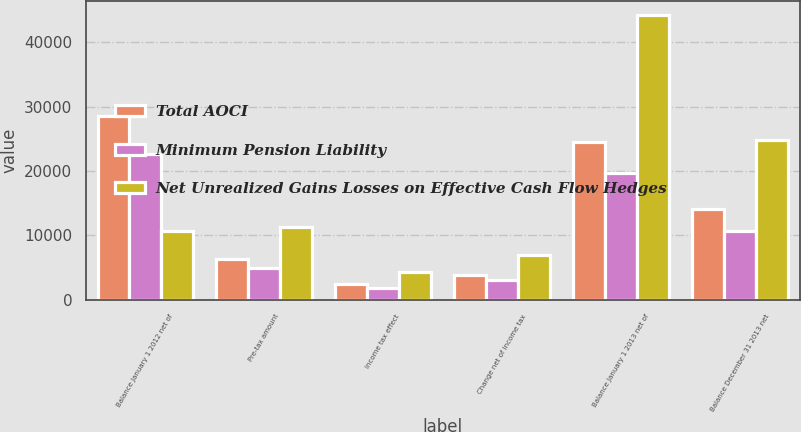<chart> <loc_0><loc_0><loc_500><loc_500><stacked_bar_chart><ecel><fcel>Balance January 1 2012 net of<fcel>Pre-tax amount<fcel>Income tax effect<fcel>Change net of income tax<fcel>Balance January 1 2013 net of<fcel>Balance December 31 2013 net<nl><fcel>Total AOCI<fcel>28460<fcel>6341<fcel>2408<fcel>3933<fcel>24527<fcel>14170<nl><fcel>Minimum Pension Liability<fcel>22715<fcel>4986<fcel>1898<fcel>3088<fcel>19627<fcel>10640<nl><fcel>Net Unrealized Gains Losses on Effective Cash Flow Hedges<fcel>10640<fcel>11327<fcel>4306<fcel>7021<fcel>44154<fcel>24810<nl></chart> 